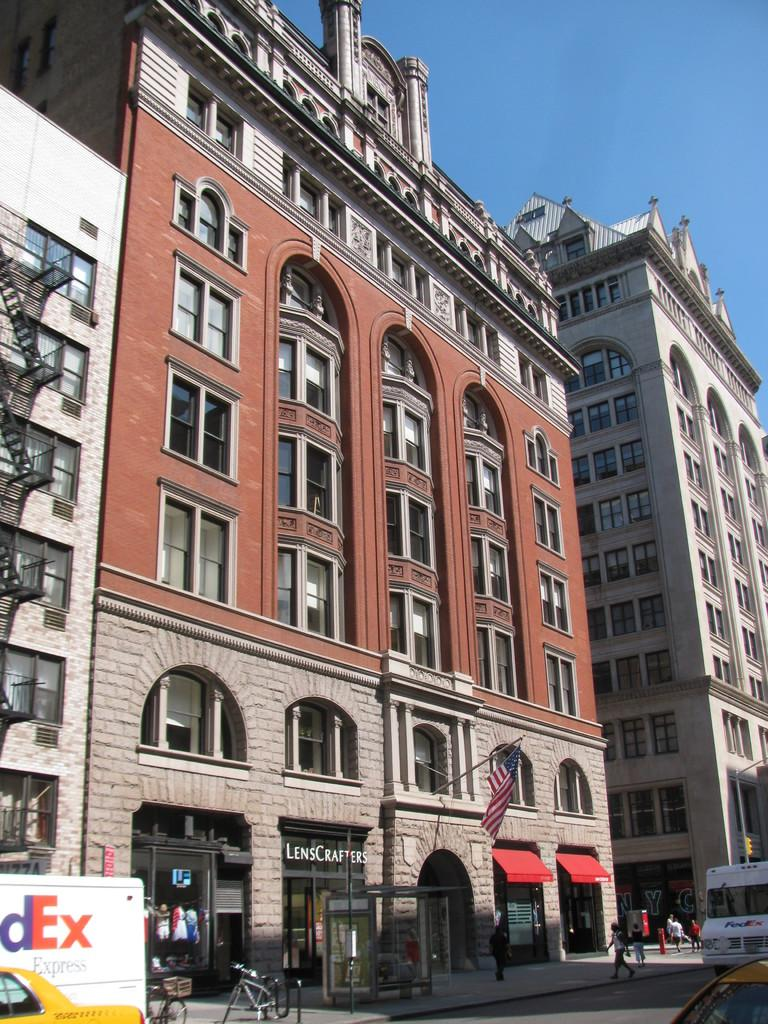What type of structures are visible in the image? There are buildings with windows in the image. What can be seen flying or waving in the image? There is a flag in the image. What type of transportation is present at the bottom of the image? Vehicles are present at the bottom of the image. Who or what is visible in the image? People are visible in the image. What part of the natural environment is visible in the image? The sky is visible in the image. What type of pear is being used to copy the flag in the image? There is no pear present in the image, nor is there any copying of the flag. How many bulbs are illuminating the buildings in the image? There is no mention of bulbs or illumination in the image; the buildings are visible during the daytime. 